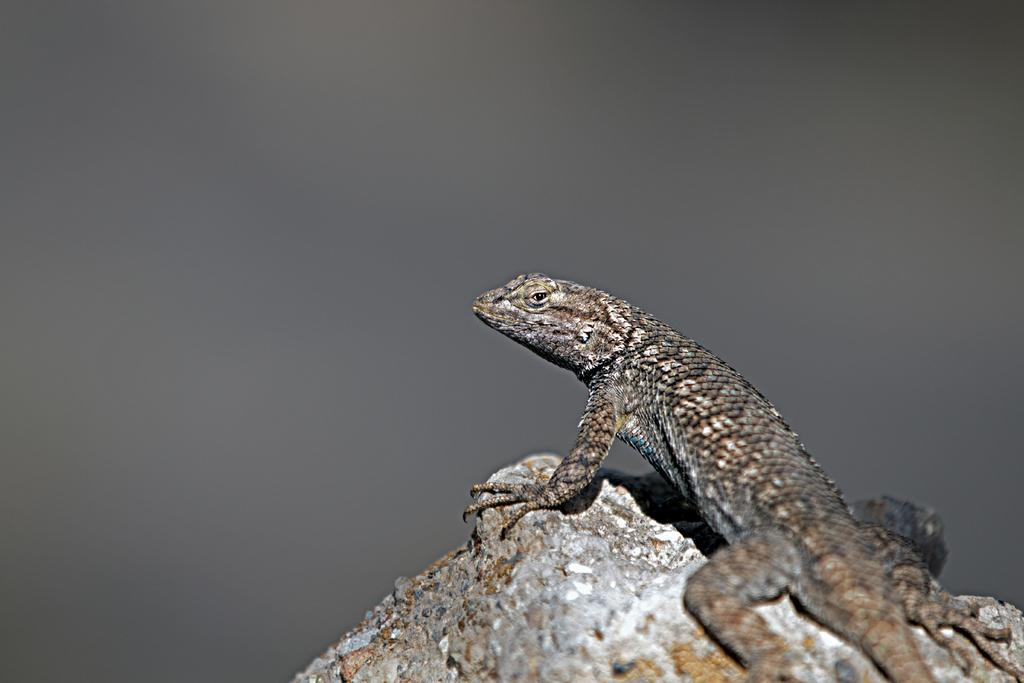What type of animal is in the image? There is a lizard in the image. Where is the lizard located in the image? The lizard is on a rock. What type of bell can be seen hanging from the lizard's neck in the image? There is no bell present in the image; it only features a lizard on a rock. 